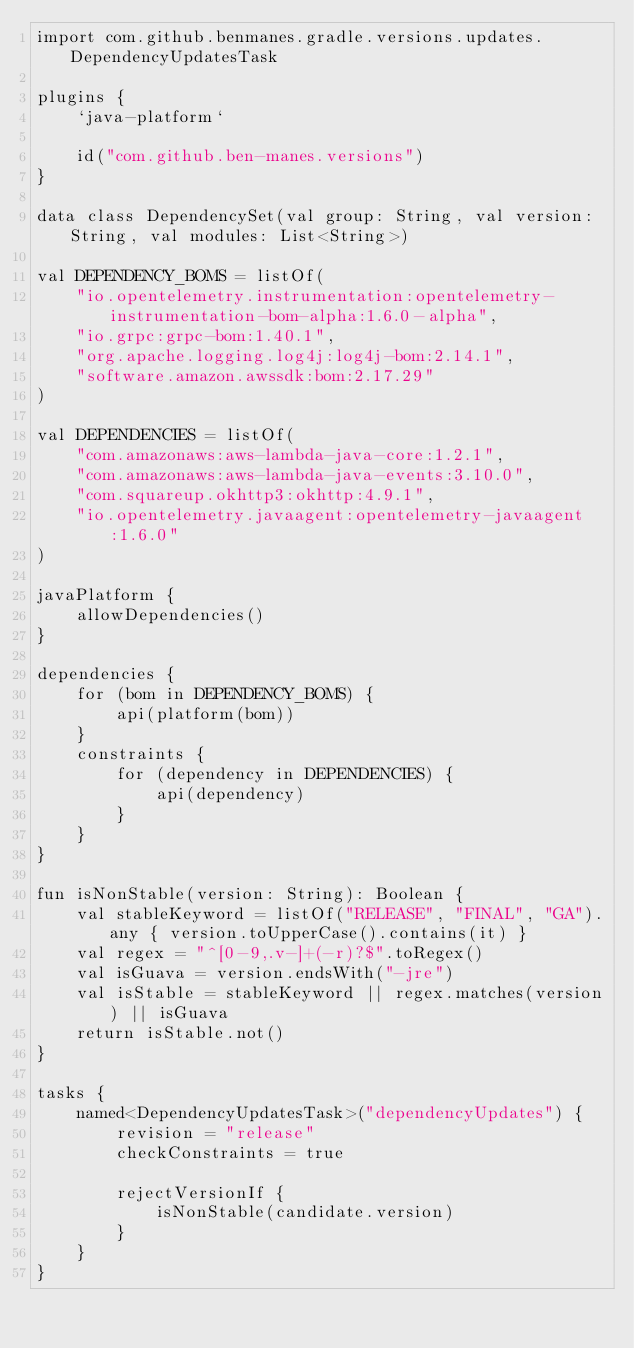Convert code to text. <code><loc_0><loc_0><loc_500><loc_500><_Kotlin_>import com.github.benmanes.gradle.versions.updates.DependencyUpdatesTask

plugins {
    `java-platform`

    id("com.github.ben-manes.versions")
}

data class DependencySet(val group: String, val version: String, val modules: List<String>)

val DEPENDENCY_BOMS = listOf(
    "io.opentelemetry.instrumentation:opentelemetry-instrumentation-bom-alpha:1.6.0-alpha",
    "io.grpc:grpc-bom:1.40.1",
    "org.apache.logging.log4j:log4j-bom:2.14.1",
    "software.amazon.awssdk:bom:2.17.29"
)

val DEPENDENCIES = listOf(
    "com.amazonaws:aws-lambda-java-core:1.2.1",
    "com.amazonaws:aws-lambda-java-events:3.10.0",
    "com.squareup.okhttp3:okhttp:4.9.1",
    "io.opentelemetry.javaagent:opentelemetry-javaagent:1.6.0"
)

javaPlatform {
    allowDependencies()
}

dependencies {
    for (bom in DEPENDENCY_BOMS) {
        api(platform(bom))
    }
    constraints {
        for (dependency in DEPENDENCIES) {
            api(dependency)
        }
    }
}

fun isNonStable(version: String): Boolean {
    val stableKeyword = listOf("RELEASE", "FINAL", "GA").any { version.toUpperCase().contains(it) }
    val regex = "^[0-9,.v-]+(-r)?$".toRegex()
    val isGuava = version.endsWith("-jre")
    val isStable = stableKeyword || regex.matches(version) || isGuava
    return isStable.not()
}

tasks {
    named<DependencyUpdatesTask>("dependencyUpdates") {
        revision = "release"
        checkConstraints = true

        rejectVersionIf {
            isNonStable(candidate.version)
        }
    }
}
</code> 